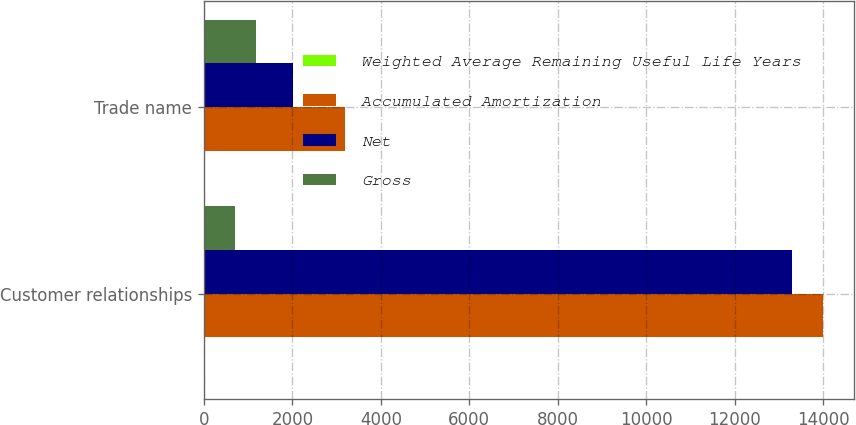Convert chart. <chart><loc_0><loc_0><loc_500><loc_500><stacked_bar_chart><ecel><fcel>Customer relationships<fcel>Trade name<nl><fcel>Weighted Average Remaining Useful Life Years<fcel>0.5<fcel>5.5<nl><fcel>Accumulated Amortization<fcel>13997<fcel>3194<nl><fcel>Net<fcel>13297<fcel>2023<nl><fcel>Gross<fcel>700<fcel>1171<nl></chart> 